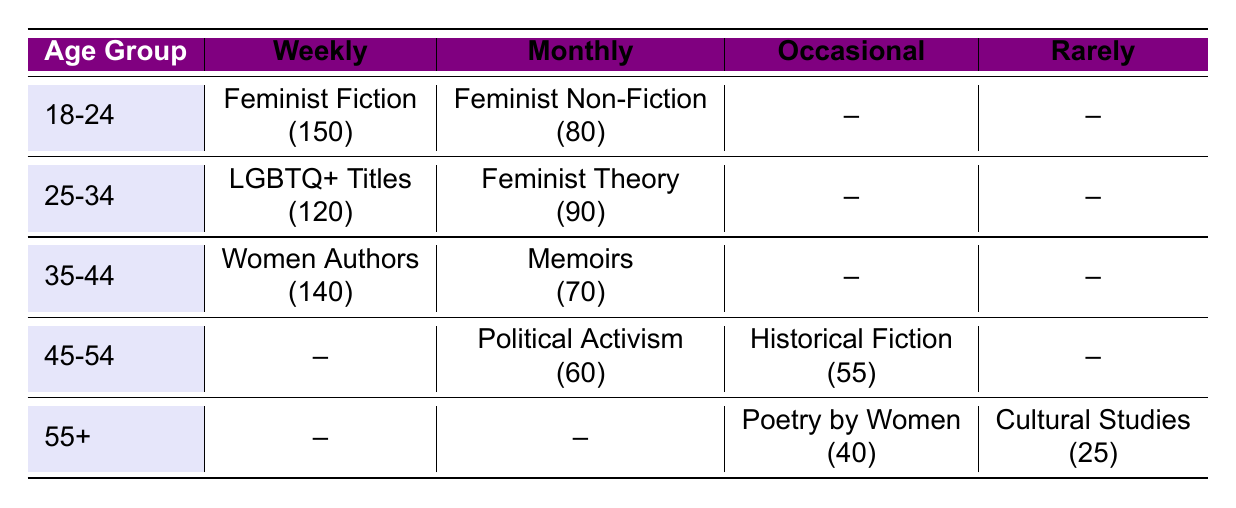What book type is most frequently purchased by the 18-24 age group? The 18-24 age group purchases "Feminist Fiction" most frequently on a weekly basis, with a count of 150.
Answer: Feminist Fiction How many customers in the 25-34 age group purchase books monthly? In the 25-34 age group, the count for "Feminist Theory" is 90, indicating that 90 customers purchase books monthly.
Answer: 90 Is there any book type purchased weekly by the 45-54 age group? The table shows no book type listed under "Weekly" for the 45-54 age group, which indicates that they do not purchase any book type weekly.
Answer: No What is the total number of customers who purchase "Political Activism" books? For "Political Activism," the count is 60 for the 45-54 age group, so the total number of customers purchasing this book type is directly 60.
Answer: 60 How many customers aged 55 and older purchase books occasionally? The 55+ age group has 40 customers purchasing "Poetry by Women" and 0 for any other book types under "Occasional," totaling 40 customers.
Answer: 40 Which age group has the highest count of customers purchasing books weekly? The 35-44 age group purchases "Women Authors" with a count of 140, which is the highest among all age groups for weekly purchases.
Answer: 35-44 age group What is the total count of customers who purchase books occasionally across all age groups? The only counts for "Occasional" purchasing are 55 for "Historical Fiction" and 40 for "Poetry by Women," totaling 55 + 40 = 95 customers.
Answer: 95 How many customers in the 18-24 age group purchase books less than monthly? The 18-24 age group has no book type listed under "Occasional" or "Rarely," indicating there are no customers purchasing less than monthly in this age group.
Answer: 0 What book type has the lowest engagement in terms of purchase frequency? "Cultural Studies" has the lowest count of 25 within the "Rarely" category across the age groups, indicating the least engagement.
Answer: Cultural Studies 